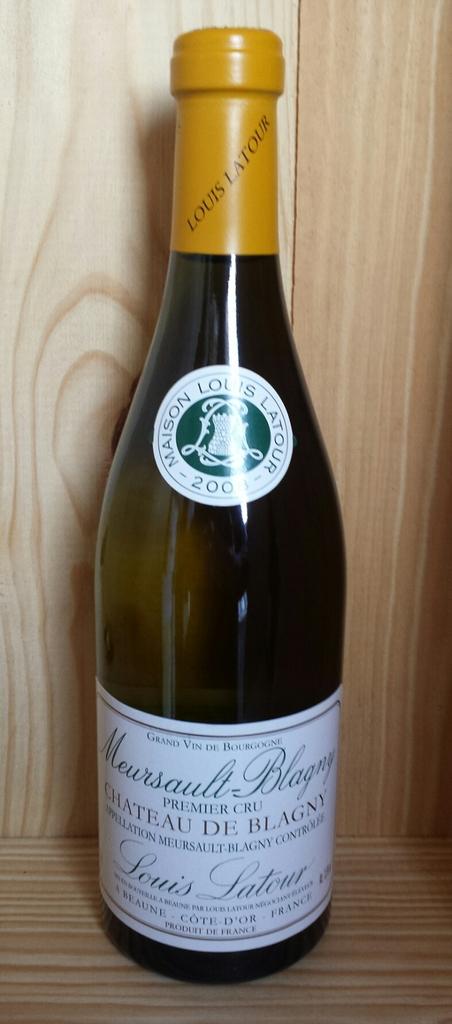Is this a french wine?
Keep it short and to the point. Yes. What is the name on the cork wrapping?
Give a very brief answer. Louis latour. 